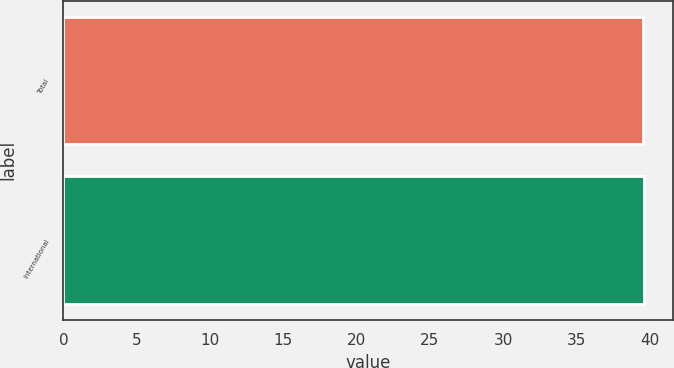<chart> <loc_0><loc_0><loc_500><loc_500><bar_chart><fcel>Total<fcel>International<nl><fcel>39.5<fcel>39.6<nl></chart> 